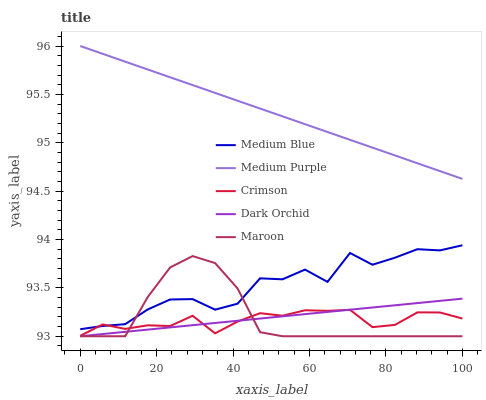Does Crimson have the minimum area under the curve?
Answer yes or no. Yes. Does Medium Purple have the maximum area under the curve?
Answer yes or no. Yes. Does Medium Blue have the minimum area under the curve?
Answer yes or no. No. Does Medium Blue have the maximum area under the curve?
Answer yes or no. No. Is Dark Orchid the smoothest?
Answer yes or no. Yes. Is Medium Blue the roughest?
Answer yes or no. Yes. Is Crimson the smoothest?
Answer yes or no. No. Is Crimson the roughest?
Answer yes or no. No. Does Crimson have the lowest value?
Answer yes or no. No. Does Medium Purple have the highest value?
Answer yes or no. Yes. Does Medium Blue have the highest value?
Answer yes or no. No. Is Medium Blue less than Medium Purple?
Answer yes or no. Yes. Is Medium Blue greater than Dark Orchid?
Answer yes or no. Yes. Does Crimson intersect Dark Orchid?
Answer yes or no. Yes. Is Crimson less than Dark Orchid?
Answer yes or no. No. Is Crimson greater than Dark Orchid?
Answer yes or no. No. Does Medium Blue intersect Medium Purple?
Answer yes or no. No. 